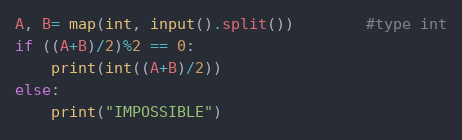<code> <loc_0><loc_0><loc_500><loc_500><_Python_>A, B= map(int, input().split())		#type int
if ((A+B)/2)%2 == 0:
	print(int((A+B)/2))
else:
	print("IMPOSSIBLE")</code> 